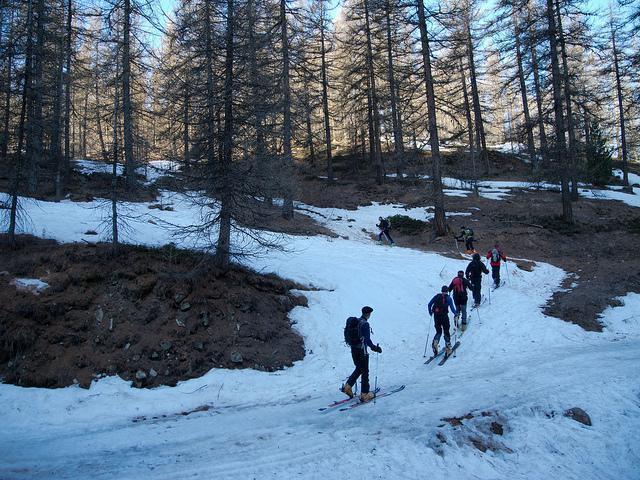Why are they skiing on level ground?
Select the accurate response from the four choices given to answer the question.
Options: Cross-country, beginners, easier, safer. Cross-country. 